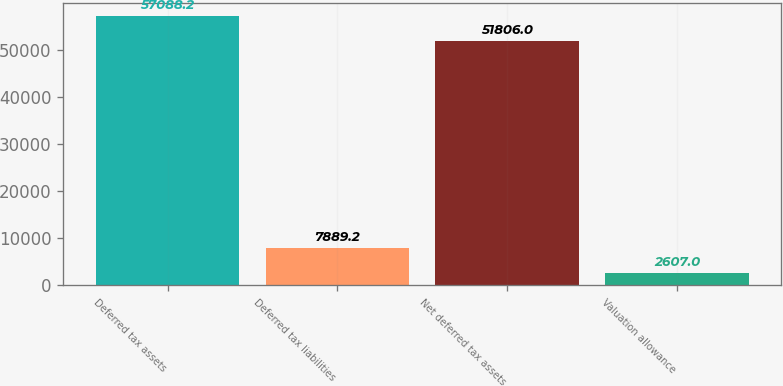<chart> <loc_0><loc_0><loc_500><loc_500><bar_chart><fcel>Deferred tax assets<fcel>Deferred tax liabilities<fcel>Net deferred tax assets<fcel>Valuation allowance<nl><fcel>57088.2<fcel>7889.2<fcel>51806<fcel>2607<nl></chart> 